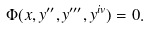Convert formula to latex. <formula><loc_0><loc_0><loc_500><loc_500>\Phi ( x , y ^ { \prime \prime } , y ^ { \prime \prime \prime } , y ^ { i v } ) = 0 .</formula> 